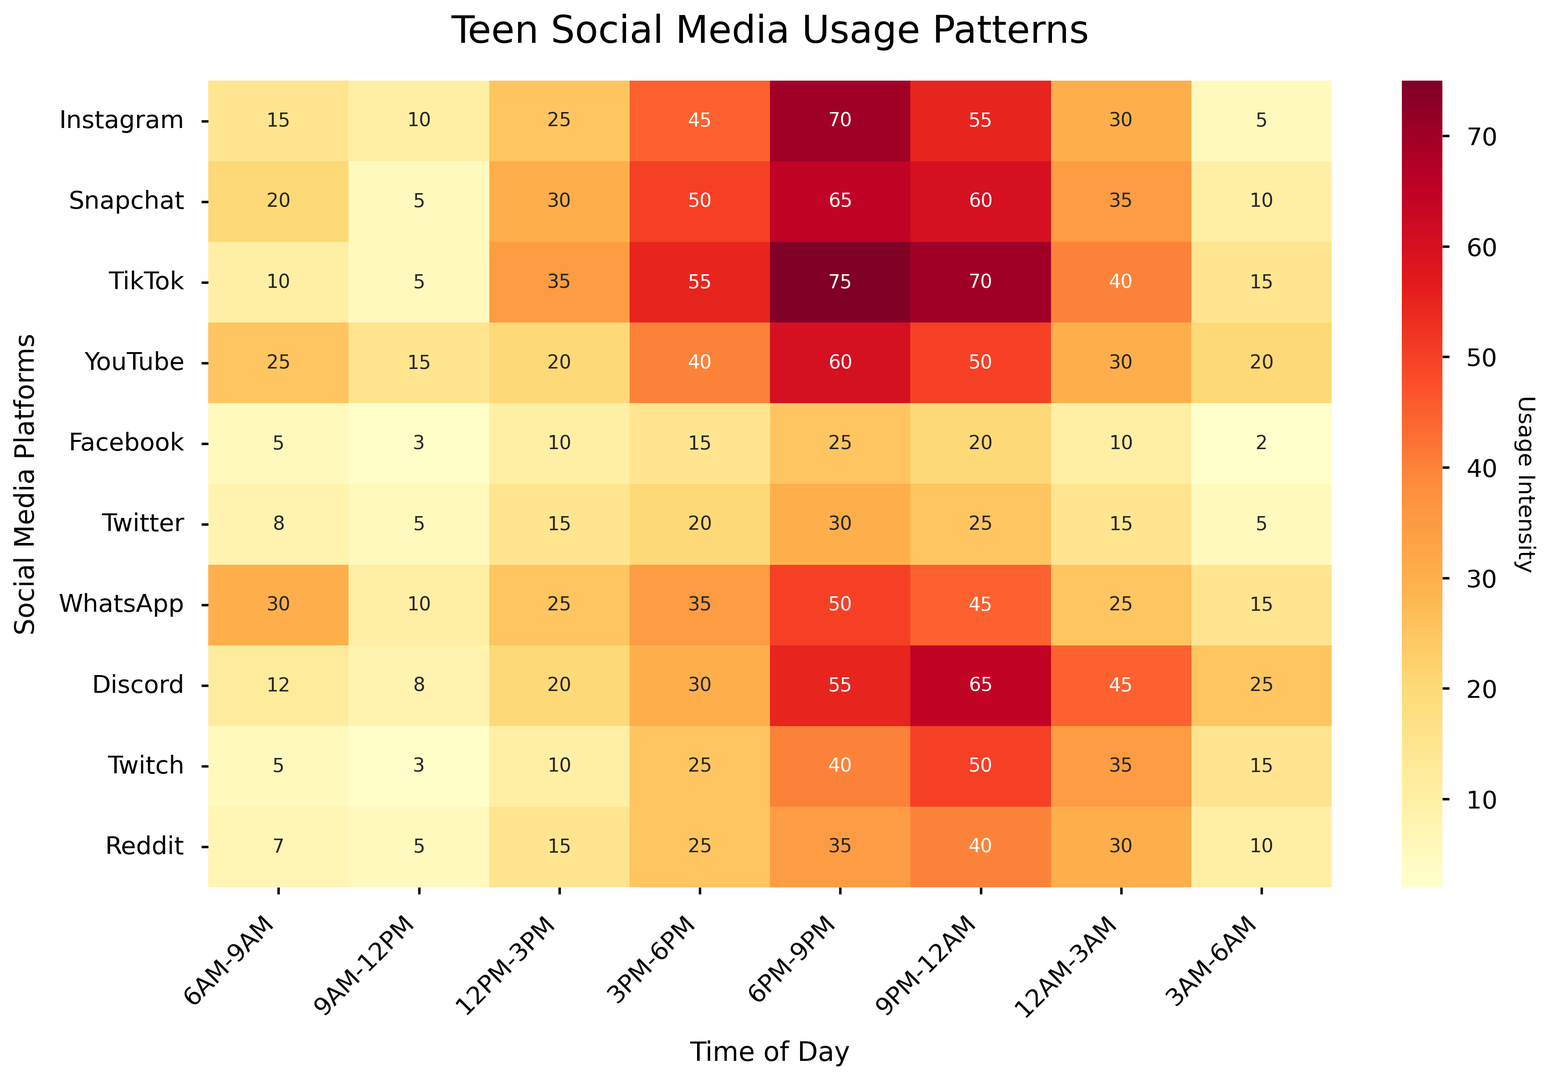What is the time of day with the highest overall usage intensity across all platforms? To determine the time of day with the highest overall usage intensity, look for the time slot that has the highest values across all platforms in the heatmap. The slot that consistently shows the darkest color bands (indicating high usage) across multiple platforms is likely the answer.
Answer: 6PM-9PM Which platform has the highest usage in the early morning (6AM-9AM) time slot? Refer to the 6AM-9AM column in the heatmap, and identify the platform with the highest value among all platforms.
Answer: WhatsApp How does Instagram's usage between 6PM-9PM compare to TikTok's usage in the same time period? Compare the values of Instagram and TikTok under the 6PM-9PM column. Based on the heatmap, Instagram has a value of 70, while TikTok has a value of 75. TikTok has a higher usage.
Answer: TikTok's usage is higher What is the sum of YouTube's usage from 3PM to 9PM? To get the sum, add YouTube's usage values for 3PM-6PM (40) and 6PM-9PM (60). 40 + 60 = 100.
Answer: 100 Which platform shows a noticeable drop in usage from 6PM-9PM to 9PM-12AM? Compare the values from 6PM-9PM and 9PM-12AM for all platforms to identify where the usage drops significantly. For instance, compare Instagram's values between these periods (70 to 55) and see if other platforms show a more significant drop. Snapchat drops from 65 to 60, Facebook from 25 to 20, etc., but Instagram shows a steep drop.
Answer: Instagram What is the average usage of Twitter during the late night periods (12AM-3AM and 3AM-6AM)? Calculate the average by summing Twitter's usage for 12AM-3AM (15) and 3AM-6AM (5), then divide by 2. (15 + 5) / 2 = 10.
Answer: 10 Which platform has the lowest usage during 9AM-12PM? Locate the column for 9AM-12PM and identify the platform with the lowest value.
Answer: Facebook What is the total usage of Facebook across all time slots? Add up the usage values for Facebook from all time slots (5 + 3 + 10 + 15 + 25 + 20 + 10 + 2). The total is 90.
Answer: 90 Between Discord and Twitch, which platform shows a higher usage intensity during the peak night period (9PM-12AM)? Compare the values in the 9PM-12AM column for Discord (65) and Twitch (50), and determine which one is higher.
Answer: Discord Looking at the color patterns, can you identify which platform has the most uniform usage throughout the day? The platform with the most consistent color shading across all time slots indicates uniform usage. WhatsApp shows relatively consistent usage across different time slots, without drastic changes in shading.
Answer: WhatsApp 